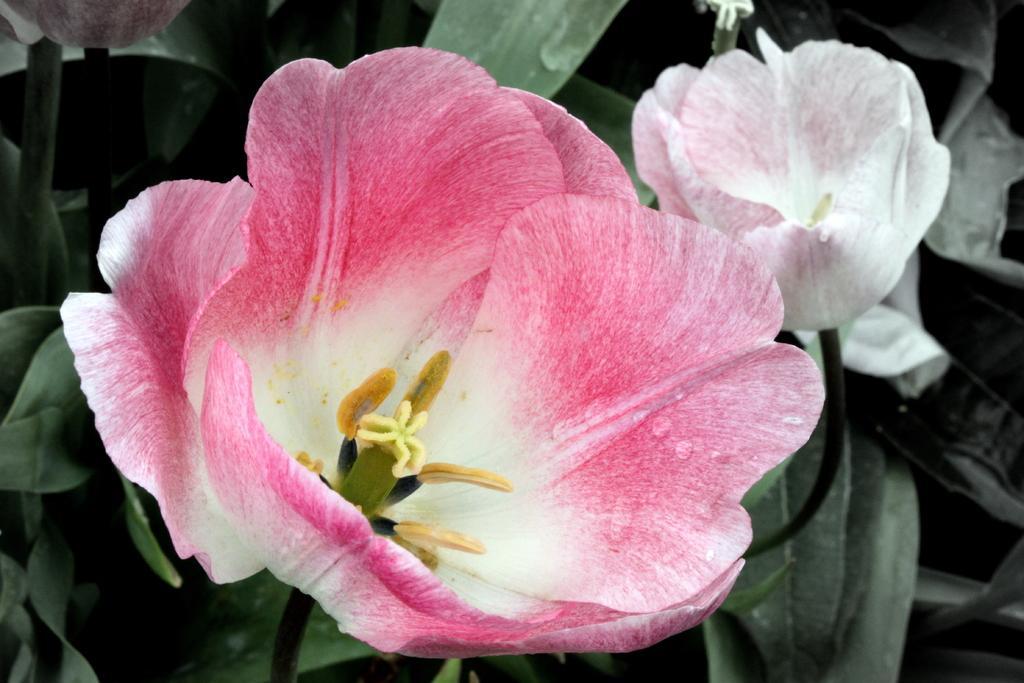Please provide a concise description of this image. This picture shows flowers and we see plants and flower is pink and white in color and another one is white in color. 